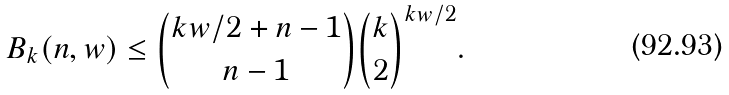<formula> <loc_0><loc_0><loc_500><loc_500>B _ { k } ( n , w ) \leq \binom { k w / 2 + n - 1 } { n - 1 } \binom { k } { 2 } ^ { k w / 2 } .</formula> 